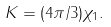Convert formula to latex. <formula><loc_0><loc_0><loc_500><loc_500>K = ( 4 \pi / 3 ) \chi _ { 1 } .</formula> 